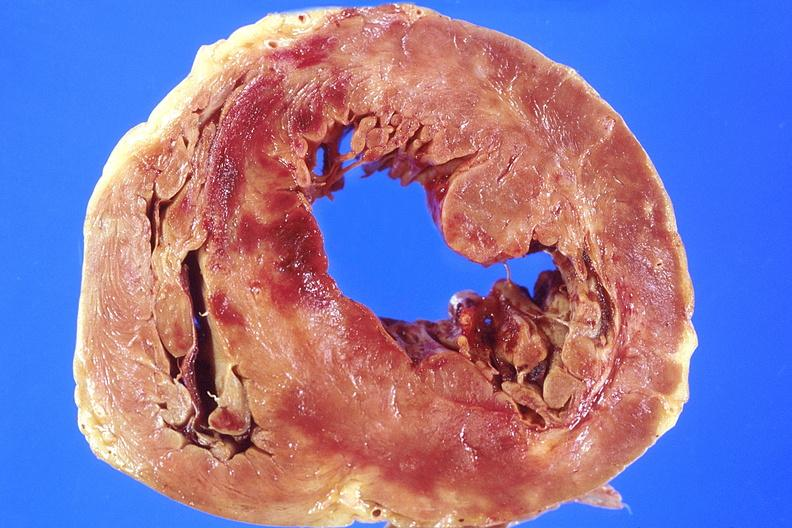s cardiovascular present?
Answer the question using a single word or phrase. Yes 